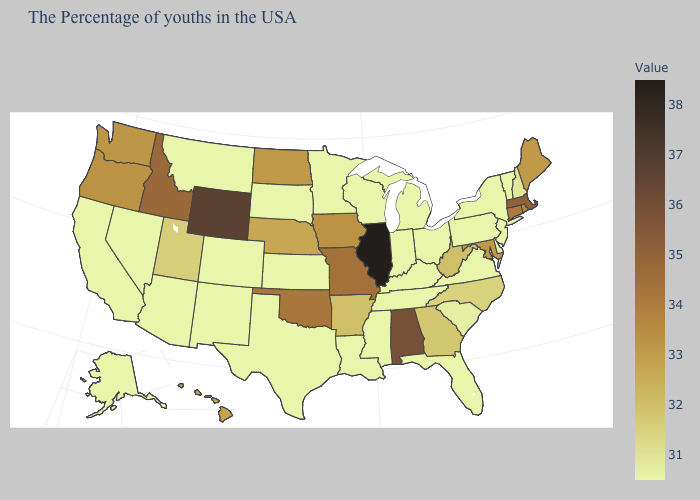Does Maine have a higher value than Kentucky?
Keep it brief. Yes. Does Tennessee have the lowest value in the USA?
Keep it brief. Yes. Which states have the highest value in the USA?
Write a very short answer. Illinois. Does Illinois have the highest value in the MidWest?
Short answer required. Yes. Does the map have missing data?
Give a very brief answer. No. Among the states that border Tennessee , which have the lowest value?
Be succinct. Virginia, Kentucky, Mississippi. 